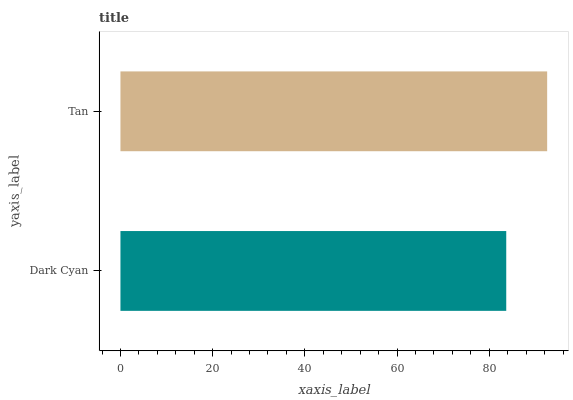Is Dark Cyan the minimum?
Answer yes or no. Yes. Is Tan the maximum?
Answer yes or no. Yes. Is Tan the minimum?
Answer yes or no. No. Is Tan greater than Dark Cyan?
Answer yes or no. Yes. Is Dark Cyan less than Tan?
Answer yes or no. Yes. Is Dark Cyan greater than Tan?
Answer yes or no. No. Is Tan less than Dark Cyan?
Answer yes or no. No. Is Tan the high median?
Answer yes or no. Yes. Is Dark Cyan the low median?
Answer yes or no. Yes. Is Dark Cyan the high median?
Answer yes or no. No. Is Tan the low median?
Answer yes or no. No. 